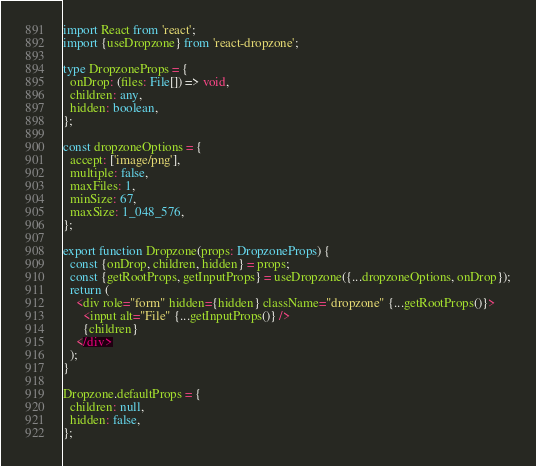Convert code to text. <code><loc_0><loc_0><loc_500><loc_500><_TypeScript_>import React from 'react';
import {useDropzone} from 'react-dropzone';

type DropzoneProps = {
  onDrop: (files: File[]) => void,
  children: any,
  hidden: boolean,
};

const dropzoneOptions = {
  accept: ['image/png'],
  multiple: false,
  maxFiles: 1,
  minSize: 67,
  maxSize: 1_048_576,
};

export function Dropzone(props: DropzoneProps) {
  const {onDrop, children, hidden} = props;
  const {getRootProps, getInputProps} = useDropzone({...dropzoneOptions, onDrop});
  return (
    <div role="form" hidden={hidden} className="dropzone" {...getRootProps()}>
      <input alt="File" {...getInputProps()} />
      {children}
    </div>
  );
}

Dropzone.defaultProps = {
  children: null,
  hidden: false,
};</code> 